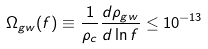<formula> <loc_0><loc_0><loc_500><loc_500>\Omega _ { g w } ( f ) \equiv \frac { 1 } { \rho _ { c } } \frac { d \rho _ { g w } } { d \ln f } \leq 1 0 ^ { - 1 3 }</formula> 